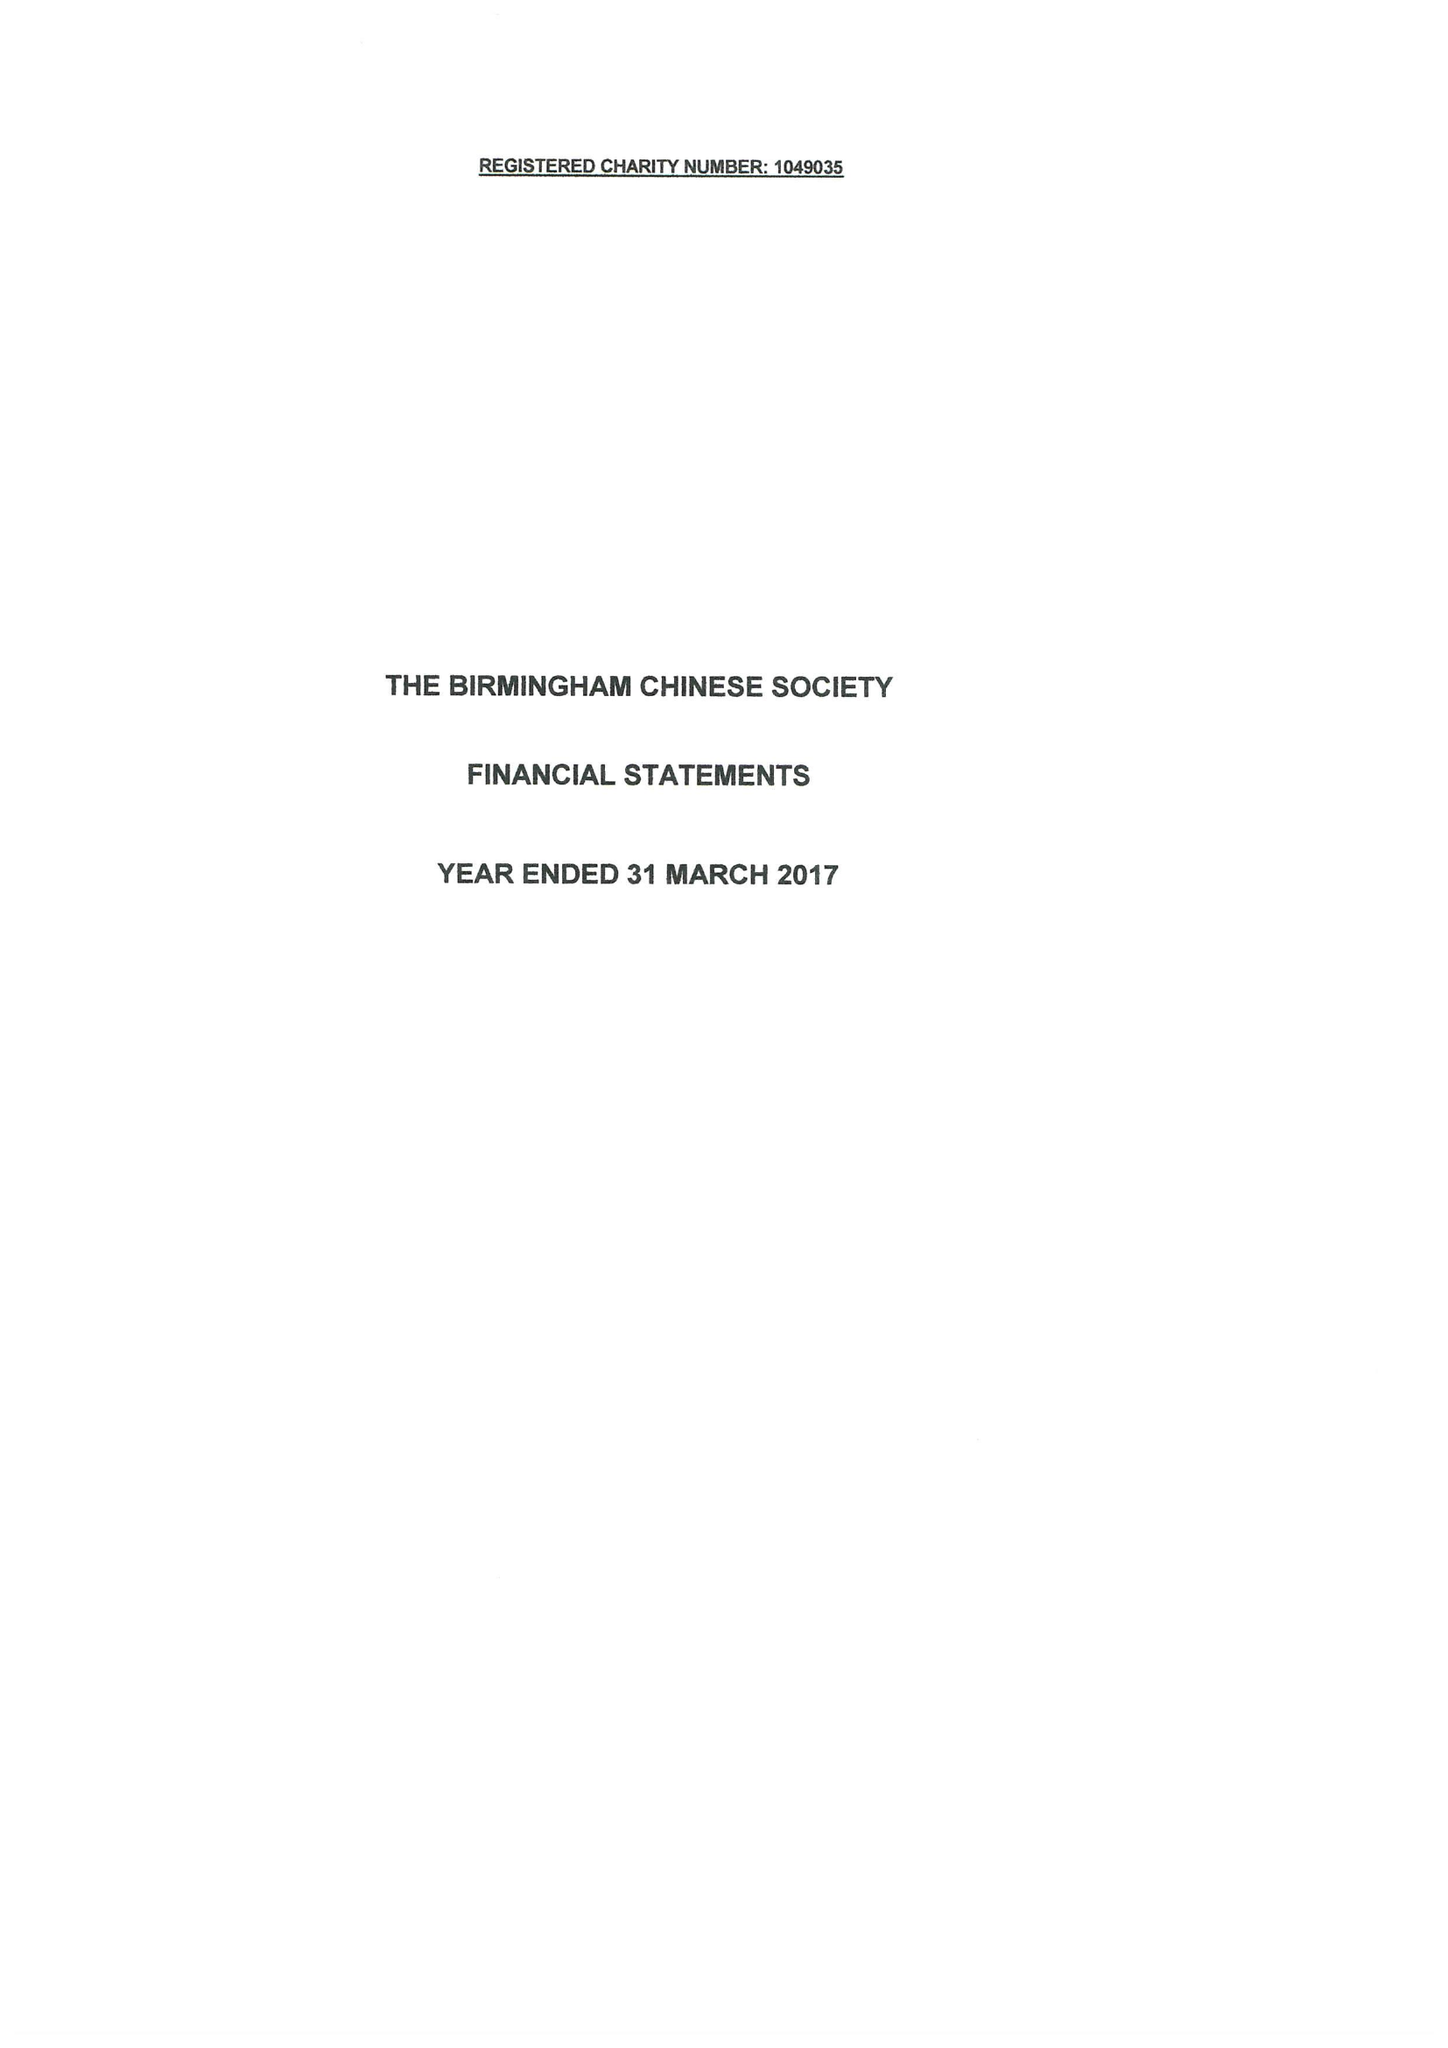What is the value for the charity_number?
Answer the question using a single word or phrase. 1049035 